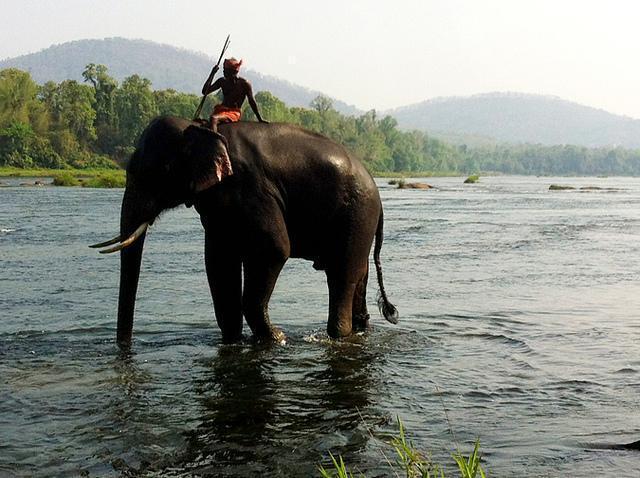How many tusks do you see?
Give a very brief answer. 2. How many clock faces does this building have?
Give a very brief answer. 0. 